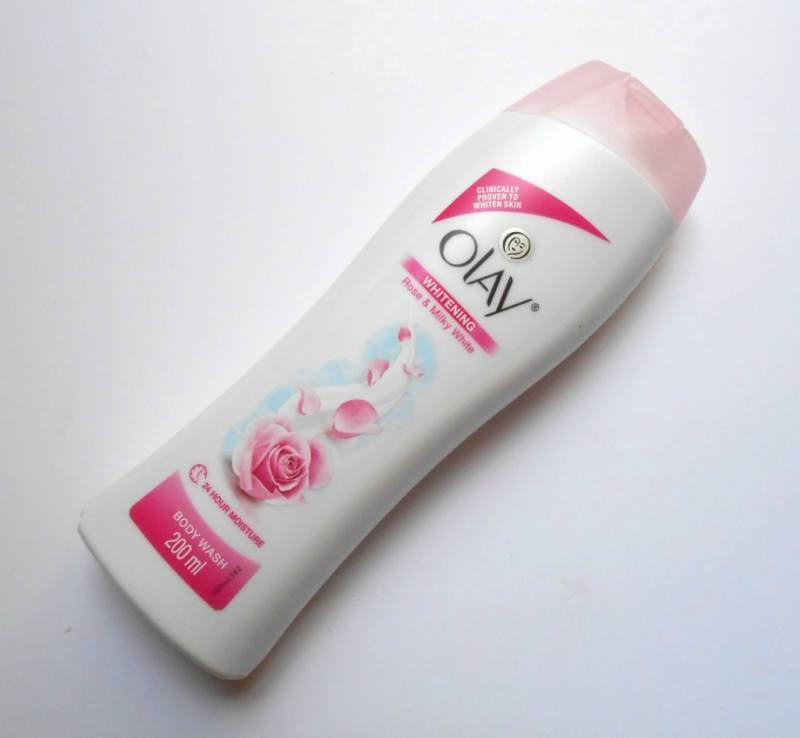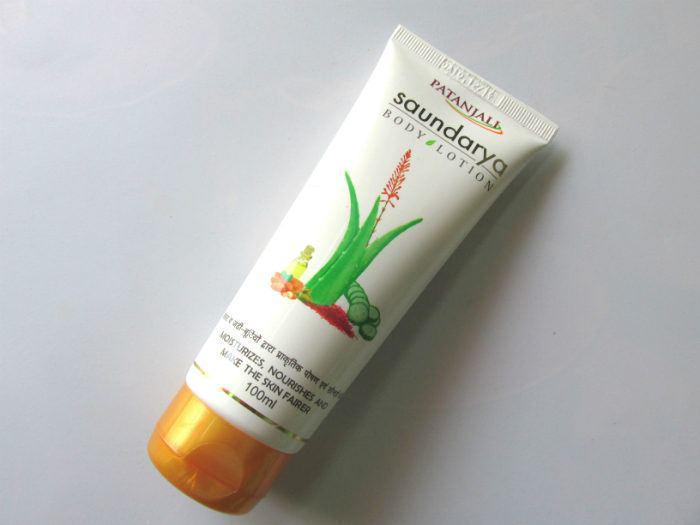The first image is the image on the left, the second image is the image on the right. Given the left and right images, does the statement "There is a torn sticker on the bottle in the image on the left." hold true? Answer yes or no. No. The first image is the image on the left, the second image is the image on the right. For the images displayed, is the sentence "All lotion bottles have dark blue caps." factually correct? Answer yes or no. No. 